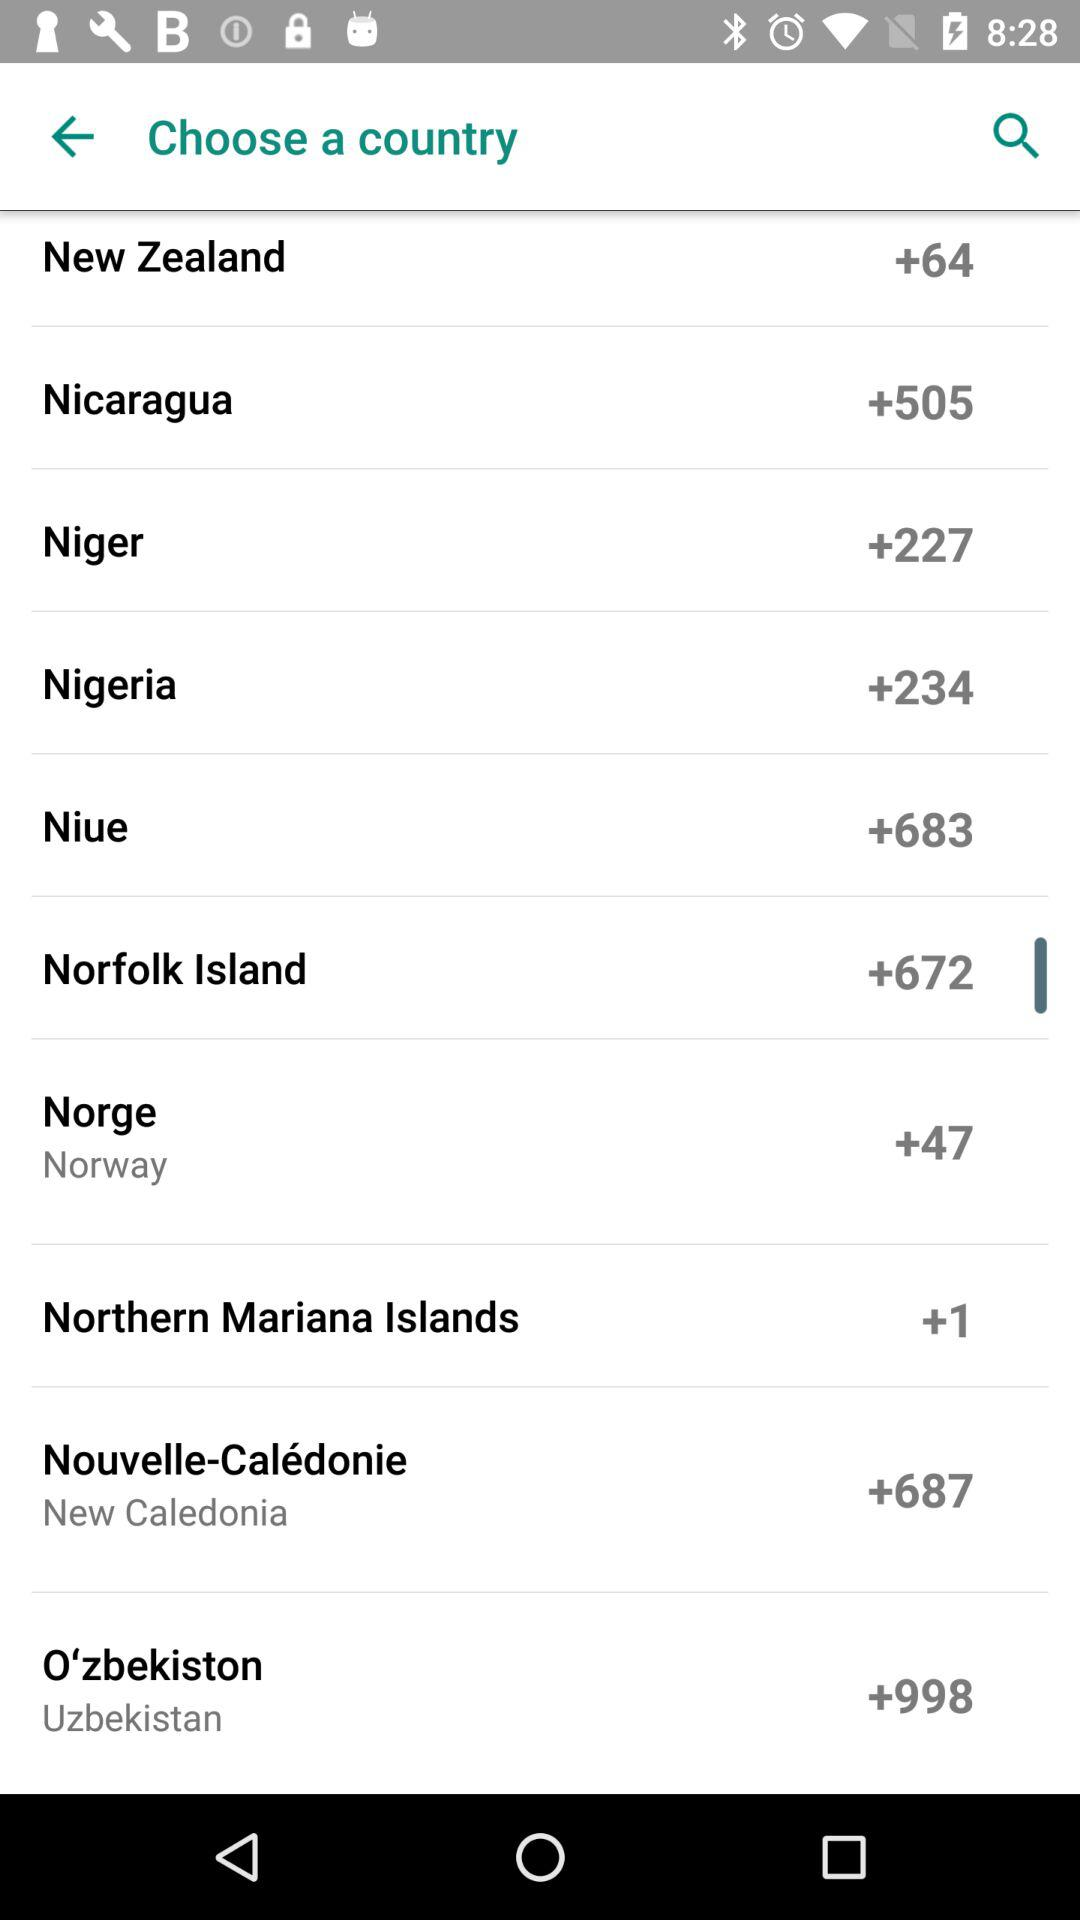Which country has +672 as a code? The country that has +672 as a code is Norfolk Island. 